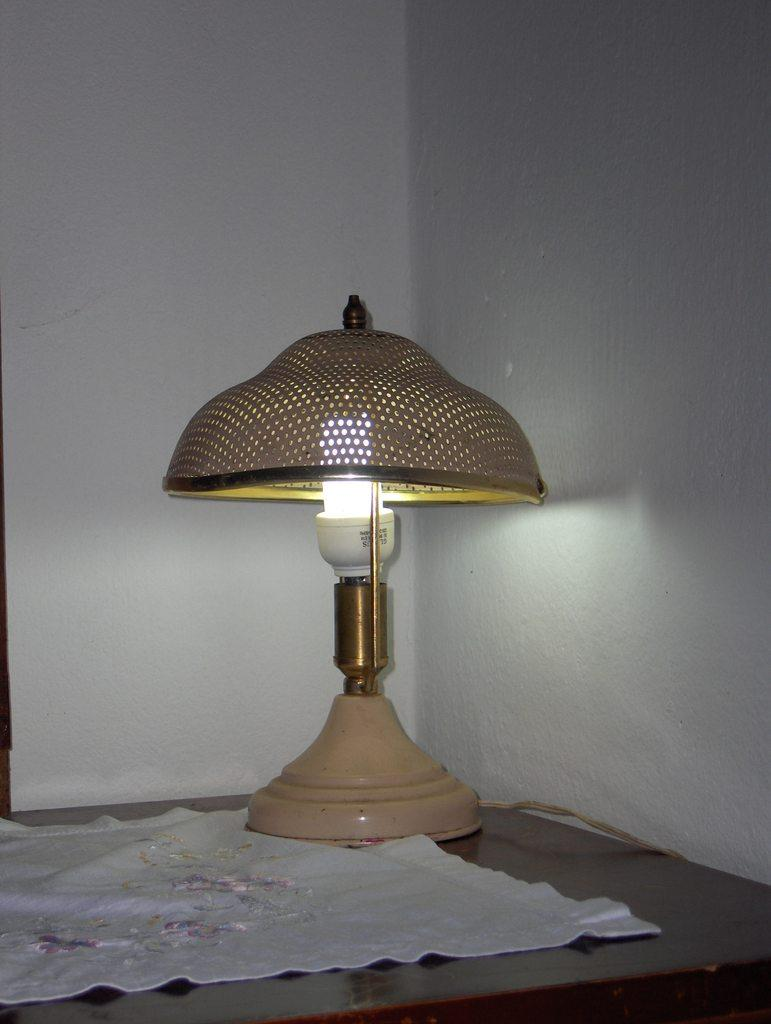What is on the table in the image? There is cloth and a lamp on the table in the image. What can be seen on the wall in the background of the image? Unfortunately, the facts provided do not give any information about the wall in the background. Can you describe the lamp on the table? The facts provided do not give any information about the appearance or type of lamp on the table. How many nails are sticking out of the cloth on the table? There is no mention of nails in the image, so we cannot answer this question. What color is the blood on the lamp in the image? There is no mention of blood in the image, so we cannot answer this question. 